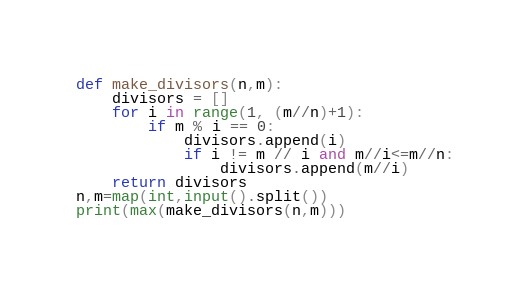<code> <loc_0><loc_0><loc_500><loc_500><_Python_>def make_divisors(n,m):
    divisors = []
    for i in range(1, (m//n)+1):
        if m % i == 0:
            divisors.append(i)
            if i != m // i and m//i<=m//n:
                divisors.append(m//i)
    return divisors
n,m=map(int,input().split())
print(max(make_divisors(n,m)))
</code> 